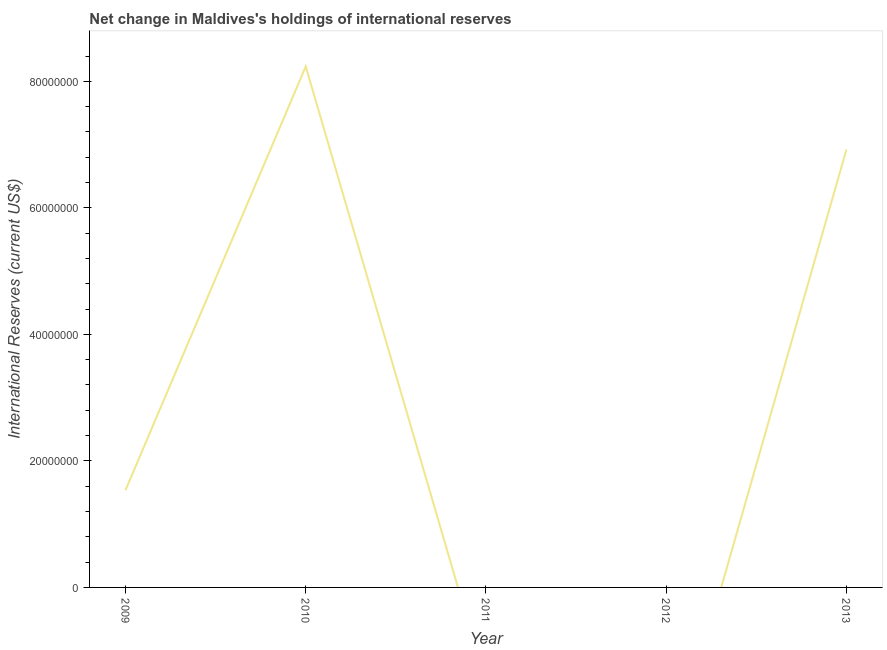What is the reserves and related items in 2012?
Your answer should be very brief. 0. Across all years, what is the maximum reserves and related items?
Provide a short and direct response. 8.23e+07. What is the sum of the reserves and related items?
Make the answer very short. 1.67e+08. What is the difference between the reserves and related items in 2010 and 2013?
Your answer should be compact. 1.31e+07. What is the average reserves and related items per year?
Offer a very short reply. 3.34e+07. What is the median reserves and related items?
Keep it short and to the point. 1.54e+07. In how many years, is the reserves and related items greater than 16000000 US$?
Offer a very short reply. 2. What is the ratio of the reserves and related items in 2009 to that in 2010?
Give a very brief answer. 0.19. Is the reserves and related items in 2009 less than that in 2013?
Offer a very short reply. Yes. Is the difference between the reserves and related items in 2010 and 2013 greater than the difference between any two years?
Make the answer very short. No. What is the difference between the highest and the second highest reserves and related items?
Your response must be concise. 1.31e+07. What is the difference between the highest and the lowest reserves and related items?
Give a very brief answer. 8.23e+07. In how many years, is the reserves and related items greater than the average reserves and related items taken over all years?
Ensure brevity in your answer.  2. Does the reserves and related items monotonically increase over the years?
Give a very brief answer. No. How many lines are there?
Give a very brief answer. 1. How many years are there in the graph?
Provide a short and direct response. 5. Are the values on the major ticks of Y-axis written in scientific E-notation?
Provide a short and direct response. No. Does the graph contain any zero values?
Offer a very short reply. Yes. What is the title of the graph?
Give a very brief answer. Net change in Maldives's holdings of international reserves. What is the label or title of the X-axis?
Offer a terse response. Year. What is the label or title of the Y-axis?
Keep it short and to the point. International Reserves (current US$). What is the International Reserves (current US$) in 2009?
Your answer should be very brief. 1.54e+07. What is the International Reserves (current US$) of 2010?
Make the answer very short. 8.23e+07. What is the International Reserves (current US$) of 2012?
Keep it short and to the point. 0. What is the International Reserves (current US$) of 2013?
Your answer should be compact. 6.92e+07. What is the difference between the International Reserves (current US$) in 2009 and 2010?
Provide a short and direct response. -6.70e+07. What is the difference between the International Reserves (current US$) in 2009 and 2013?
Make the answer very short. -5.39e+07. What is the difference between the International Reserves (current US$) in 2010 and 2013?
Your response must be concise. 1.31e+07. What is the ratio of the International Reserves (current US$) in 2009 to that in 2010?
Your response must be concise. 0.19. What is the ratio of the International Reserves (current US$) in 2009 to that in 2013?
Offer a terse response. 0.22. What is the ratio of the International Reserves (current US$) in 2010 to that in 2013?
Give a very brief answer. 1.19. 